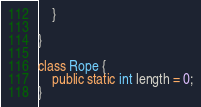<code> <loc_0><loc_0><loc_500><loc_500><_Java_>    }

}

class Rope {
    public static int length = 0;
}
</code> 